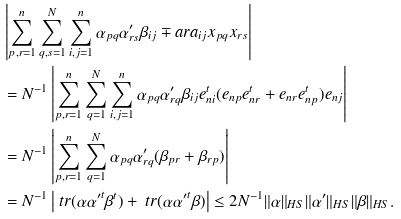Convert formula to latex. <formula><loc_0><loc_0><loc_500><loc_500>& \left | \sum _ { p , r = 1 } ^ { n } \sum _ { q , s = 1 } ^ { N } \sum _ { i , j = 1 } ^ { n } \alpha _ { p q } \alpha _ { r s } ^ { \prime } \beta _ { i j } \mp a r { a _ { i j } } { x _ { p q } } { x _ { r s } } \right | \\ & = N ^ { - 1 } \left | \sum _ { p , r = 1 } ^ { n } \sum _ { q = 1 } ^ { N } \sum _ { i , j = 1 } ^ { n } \alpha _ { p q } \alpha _ { r q } ^ { \prime } \beta _ { i j } e _ { n i } ^ { t } ( e _ { n p } e _ { n r } ^ { t } + e _ { n r } e _ { n p } ^ { t } ) e _ { n j } \right | \\ & = N ^ { - 1 } \left | \sum _ { p , r = 1 } ^ { n } \sum _ { q = 1 } ^ { N } \alpha _ { p q } \alpha _ { r q } ^ { \prime } ( \beta _ { p r } + \beta _ { r p } ) \right | \\ & = N ^ { - 1 } \left | \ t r ( \alpha { \alpha ^ { \prime } } ^ { t } \beta ^ { t } ) + \ t r ( \alpha { \alpha ^ { \prime } } ^ { t } \beta ) \right | \leq 2 N ^ { - 1 } \| \alpha \| _ { H S } \| \alpha ^ { \prime } \| _ { H S } \| \beta \| _ { H S } .</formula> 